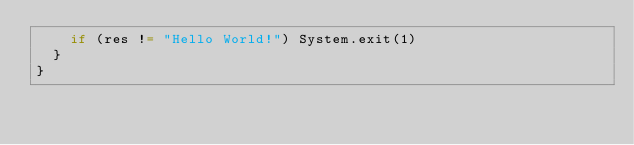<code> <loc_0><loc_0><loc_500><loc_500><_Scala_>    if (res != "Hello World!") System.exit(1)
  }
}</code> 